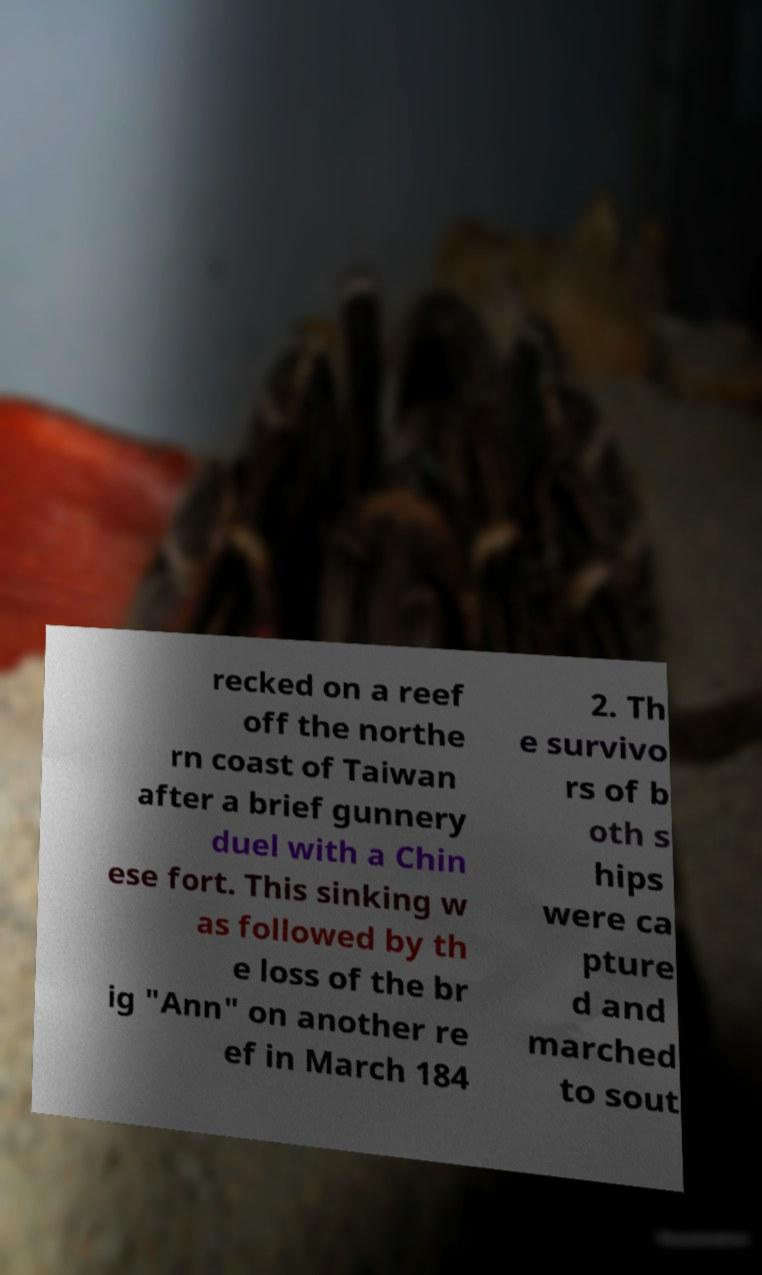For documentation purposes, I need the text within this image transcribed. Could you provide that? recked on a reef off the northe rn coast of Taiwan after a brief gunnery duel with a Chin ese fort. This sinking w as followed by th e loss of the br ig "Ann" on another re ef in March 184 2. Th e survivo rs of b oth s hips were ca pture d and marched to sout 